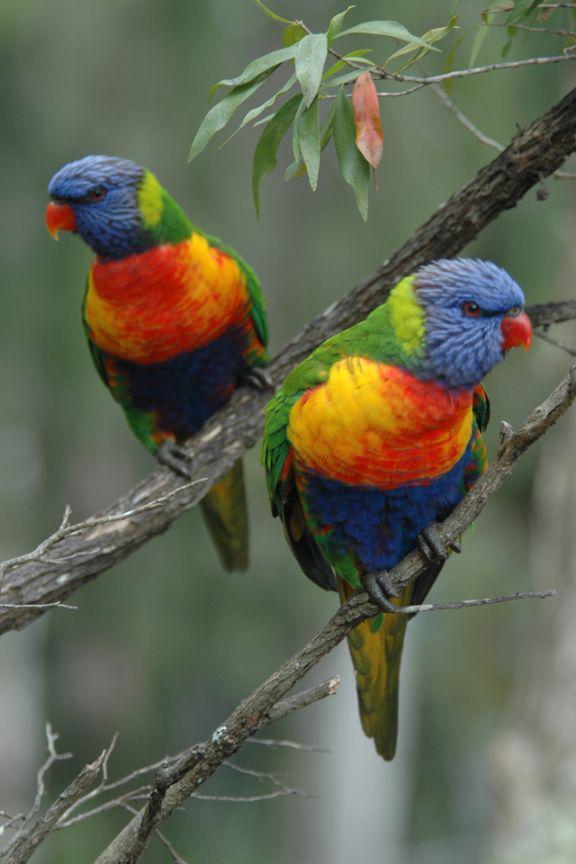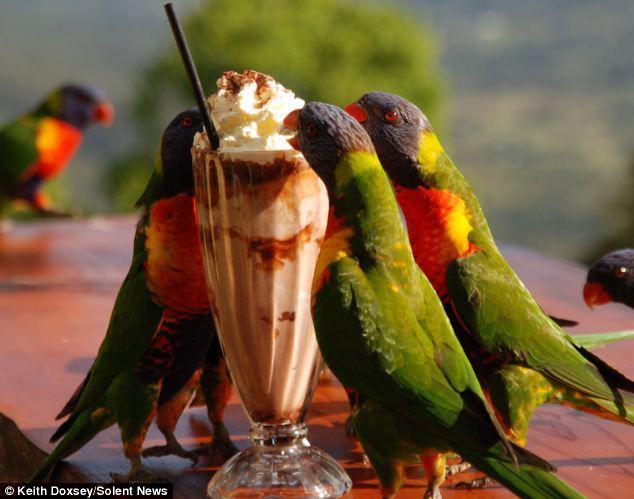The first image is the image on the left, the second image is the image on the right. Examine the images to the left and right. Is the description "At least one of the images shows three colourful parrots perched on a branch." accurate? Answer yes or no. No. The first image is the image on the left, the second image is the image on the right. Considering the images on both sides, is "At least two parrots are perched in branches containing bright red flower-like growths." valid? Answer yes or no. No. The first image is the image on the left, the second image is the image on the right. Evaluate the accuracy of this statement regarding the images: "An image shows a single parrot which is not in flight.". Is it true? Answer yes or no. No. 